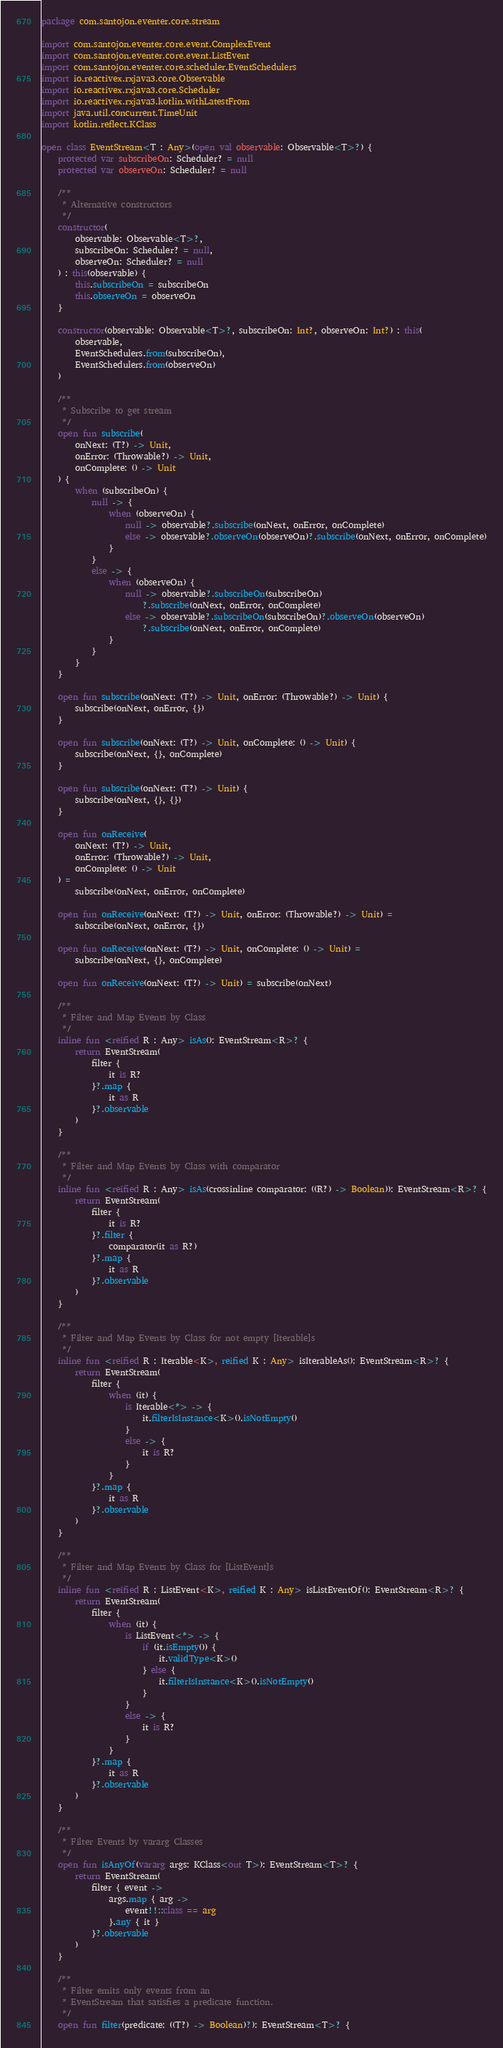<code> <loc_0><loc_0><loc_500><loc_500><_Kotlin_>package com.santojon.eventer.core.stream

import com.santojon.eventer.core.event.ComplexEvent
import com.santojon.eventer.core.event.ListEvent
import com.santojon.eventer.core.scheduler.EventSchedulers
import io.reactivex.rxjava3.core.Observable
import io.reactivex.rxjava3.core.Scheduler
import io.reactivex.rxjava3.kotlin.withLatestFrom
import java.util.concurrent.TimeUnit
import kotlin.reflect.KClass

open class EventStream<T : Any>(open val observable: Observable<T>?) {
    protected var subscribeOn: Scheduler? = null
    protected var observeOn: Scheduler? = null

    /**
     * Alternative constructors
     */
    constructor(
        observable: Observable<T>?,
        subscribeOn: Scheduler? = null,
        observeOn: Scheduler? = null
    ) : this(observable) {
        this.subscribeOn = subscribeOn
        this.observeOn = observeOn
    }

    constructor(observable: Observable<T>?, subscribeOn: Int?, observeOn: Int?) : this(
        observable,
        EventSchedulers.from(subscribeOn),
        EventSchedulers.from(observeOn)
    )

    /**
     * Subscribe to get stream
     */
    open fun subscribe(
        onNext: (T?) -> Unit,
        onError: (Throwable?) -> Unit,
        onComplete: () -> Unit
    ) {
        when (subscribeOn) {
            null -> {
                when (observeOn) {
                    null -> observable?.subscribe(onNext, onError, onComplete)
                    else -> observable?.observeOn(observeOn)?.subscribe(onNext, onError, onComplete)
                }
            }
            else -> {
                when (observeOn) {
                    null -> observable?.subscribeOn(subscribeOn)
                        ?.subscribe(onNext, onError, onComplete)
                    else -> observable?.subscribeOn(subscribeOn)?.observeOn(observeOn)
                        ?.subscribe(onNext, onError, onComplete)
                }
            }
        }
    }

    open fun subscribe(onNext: (T?) -> Unit, onError: (Throwable?) -> Unit) {
        subscribe(onNext, onError, {})
    }

    open fun subscribe(onNext: (T?) -> Unit, onComplete: () -> Unit) {
        subscribe(onNext, {}, onComplete)
    }

    open fun subscribe(onNext: (T?) -> Unit) {
        subscribe(onNext, {}, {})
    }

    open fun onReceive(
        onNext: (T?) -> Unit,
        onError: (Throwable?) -> Unit,
        onComplete: () -> Unit
    ) =
        subscribe(onNext, onError, onComplete)

    open fun onReceive(onNext: (T?) -> Unit, onError: (Throwable?) -> Unit) =
        subscribe(onNext, onError, {})

    open fun onReceive(onNext: (T?) -> Unit, onComplete: () -> Unit) =
        subscribe(onNext, {}, onComplete)

    open fun onReceive(onNext: (T?) -> Unit) = subscribe(onNext)

    /**
     * Filter and Map Events by Class
     */
    inline fun <reified R : Any> isAs(): EventStream<R>? {
        return EventStream(
            filter {
                it is R?
            }?.map {
                it as R
            }?.observable
        )
    }

    /**
     * Filter and Map Events by Class with comparator
     */
    inline fun <reified R : Any> isAs(crossinline comparator: ((R?) -> Boolean)): EventStream<R>? {
        return EventStream(
            filter {
                it is R?
            }?.filter {
                comparator(it as R?)
            }?.map {
                it as R
            }?.observable
        )
    }

    /**
     * Filter and Map Events by Class for not empty [Iterable]s
     */
    inline fun <reified R : Iterable<K>, reified K : Any> isIterableAs(): EventStream<R>? {
        return EventStream(
            filter {
                when (it) {
                    is Iterable<*> -> {
                        it.filterIsInstance<K>().isNotEmpty()
                    }
                    else -> {
                        it is R?
                    }
                }
            }?.map {
                it as R
            }?.observable
        )
    }

    /**
     * Filter and Map Events by Class for [ListEvent]s
     */
    inline fun <reified R : ListEvent<K>, reified K : Any> isListEventOf(): EventStream<R>? {
        return EventStream(
            filter {
                when (it) {
                    is ListEvent<*> -> {
                        if (it.isEmpty()) {
                            it.validType<K>()
                        } else {
                            it.filterIsInstance<K>().isNotEmpty()
                        }
                    }
                    else -> {
                        it is R?
                    }
                }
            }?.map {
                it as R
            }?.observable
        )
    }

    /**
     * Filter Events by vararg Classes
     */
    open fun isAnyOf(vararg args: KClass<out T>): EventStream<T>? {
        return EventStream(
            filter { event ->
                args.map { arg ->
                    event!!::class == arg
                }.any { it }
            }?.observable
        )
    }

    /**
     * Filter emits only events from an
     * EventStream that satisfies a predicate function.
     */
    open fun filter(predicate: ((T?) -> Boolean)?): EventStream<T>? {</code> 